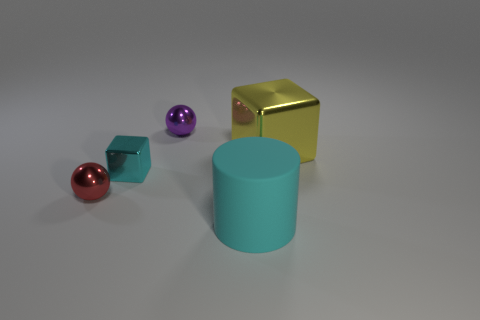Is the shape of the big matte object the same as the tiny purple thing?
Your response must be concise. No. What is the color of the cube that is the same size as the cylinder?
Offer a very short reply. Yellow. Is there a tiny shiny object that has the same color as the big cylinder?
Your answer should be compact. Yes. Are any large yellow shiny objects visible?
Provide a succinct answer. Yes. Is the cyan thing that is in front of the small cyan metallic thing made of the same material as the yellow object?
Keep it short and to the point. No. What size is the metal cube that is the same color as the matte object?
Provide a short and direct response. Small. What number of purple metallic objects have the same size as the cyan cube?
Offer a very short reply. 1. Are there the same number of large cubes that are in front of the yellow metal thing and large metal objects?
Provide a succinct answer. No. How many metal objects are right of the large matte object and to the left of the cyan shiny object?
Make the answer very short. 0. What size is the yellow cube that is the same material as the purple sphere?
Provide a succinct answer. Large. 